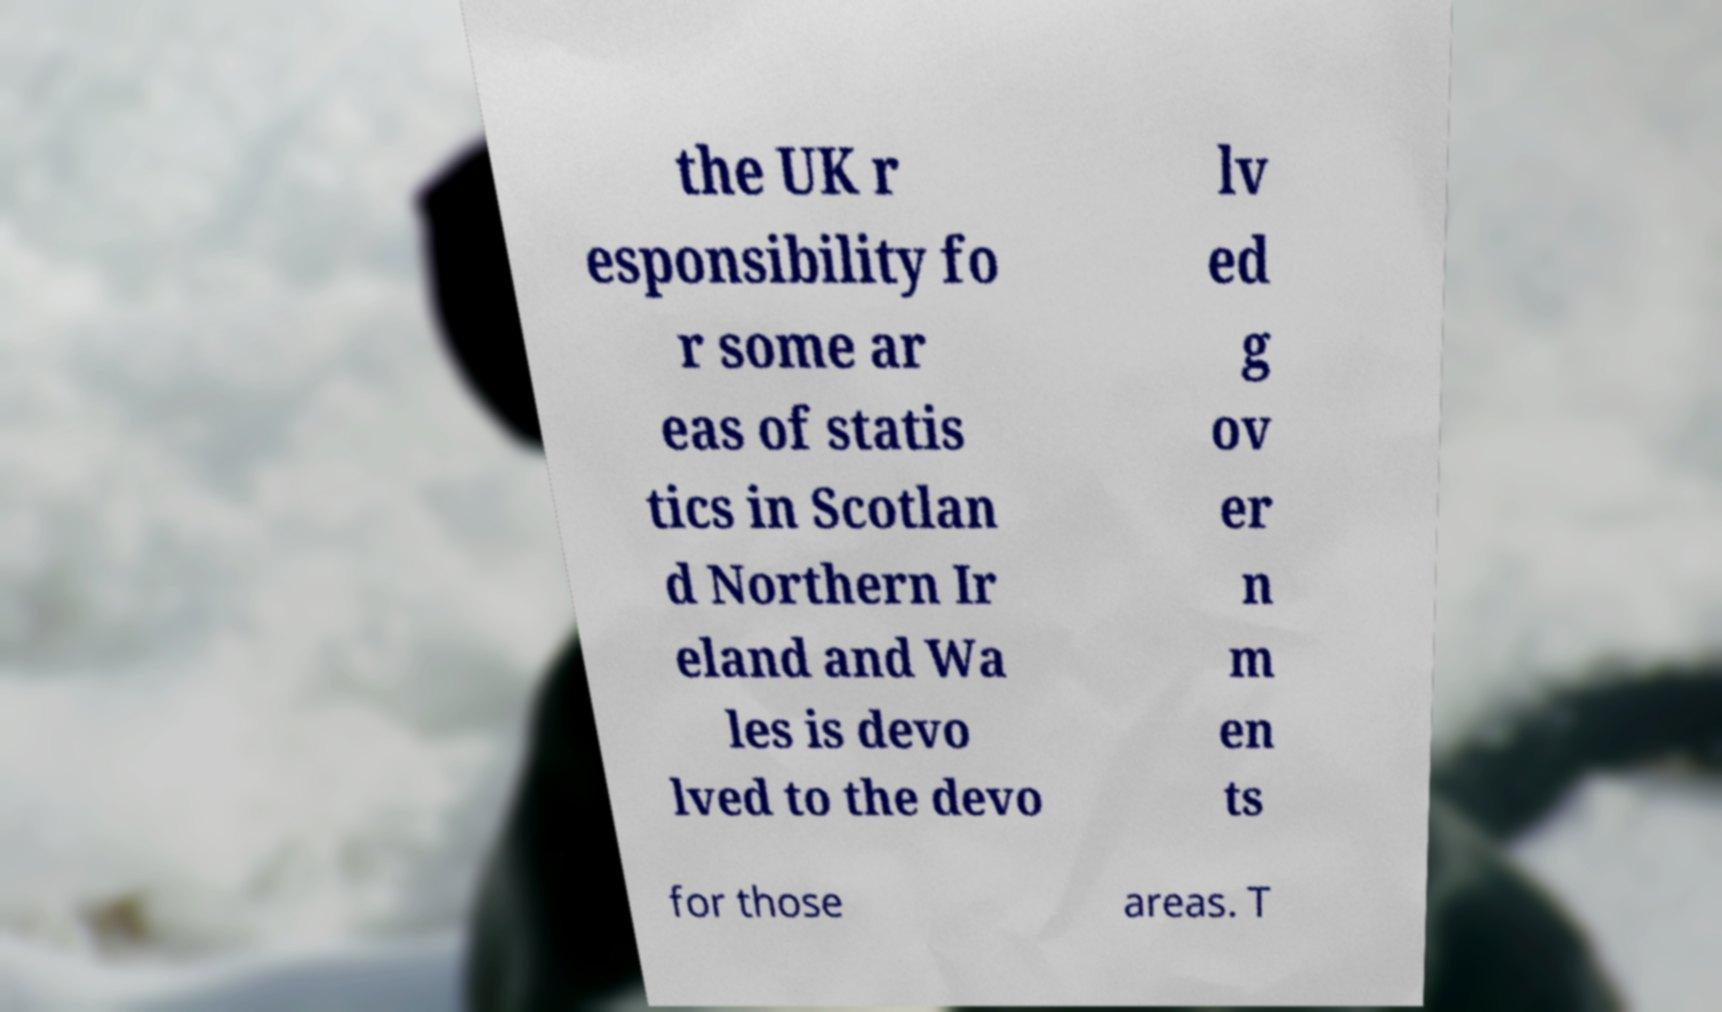Can you accurately transcribe the text from the provided image for me? the UK r esponsibility fo r some ar eas of statis tics in Scotlan d Northern Ir eland and Wa les is devo lved to the devo lv ed g ov er n m en ts for those areas. T 